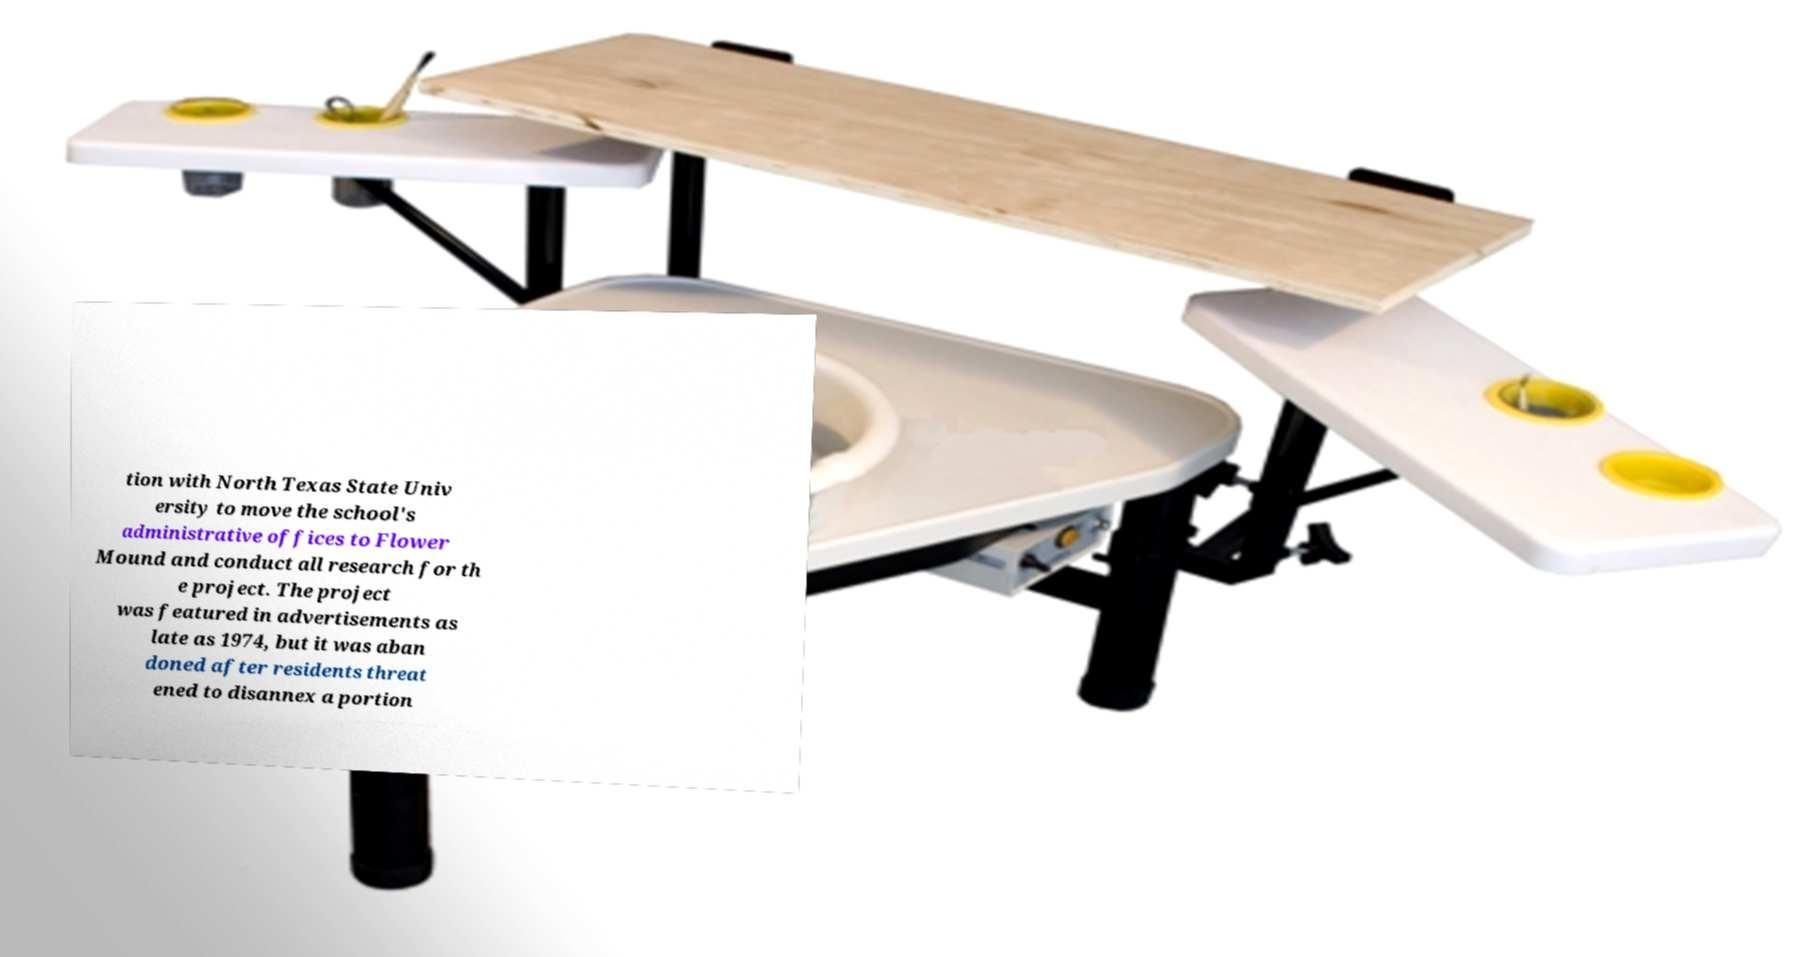Please read and relay the text visible in this image. What does it say? tion with North Texas State Univ ersity to move the school's administrative offices to Flower Mound and conduct all research for th e project. The project was featured in advertisements as late as 1974, but it was aban doned after residents threat ened to disannex a portion 